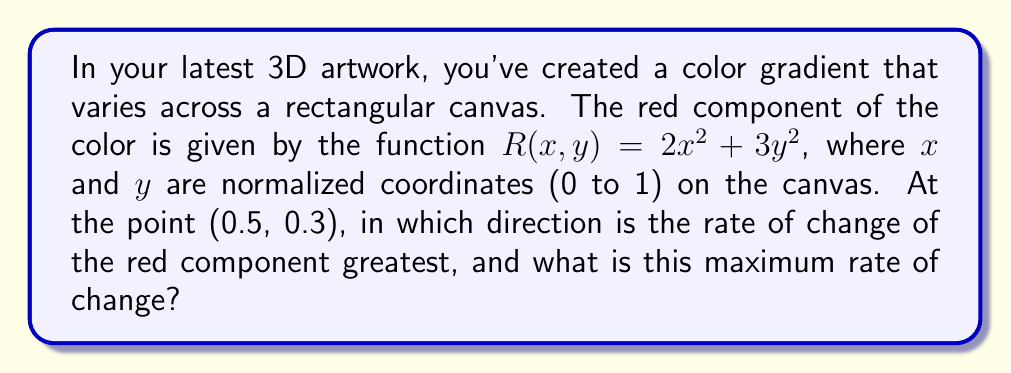Show me your answer to this math problem. To solve this problem, we need to use the concept of the gradient vector and its magnitude. The gradient vector points in the direction of steepest increase of the function and its magnitude gives the maximum rate of change.

Step 1: Calculate the partial derivatives of $R$ with respect to $x$ and $y$.
$$\frac{\partial R}{\partial x} = 4x$$
$$\frac{\partial R}{\partial y} = 6y$$

Step 2: Form the gradient vector at the point (0.5, 0.3).
$$\nabla R(0.5, 0.3) = \left(\frac{\partial R}{\partial x}, \frac{\partial R}{\partial y}\right) = (4(0.5), 6(0.3)) = (2, 1.8)$$

Step 3: The direction of steepest increase is given by the gradient vector (2, 1.8).

Step 4: Calculate the magnitude of the gradient vector to find the maximum rate of change.
$$\text{Maximum rate of change} = \|\nabla R(0.5, 0.3)\| = \sqrt{2^2 + 1.8^2} = \sqrt{7.24} \approx 2.69$$

Therefore, at the point (0.5, 0.3), the rate of change of the red component is greatest in the direction of the vector (2, 1.8), and the maximum rate of change is approximately 2.69 units per unit distance in the normalized coordinate system.
Answer: Direction: (2, 1.8); Maximum rate: 2.69 